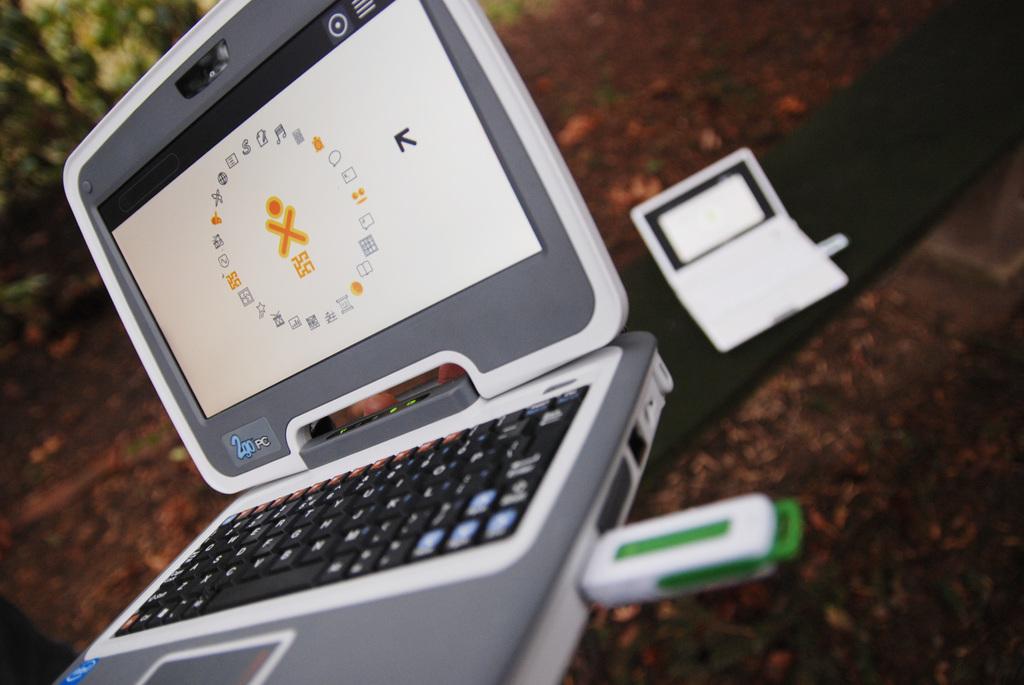What letter is displayed in the center of the laptop screen?
Your answer should be compact. X. 